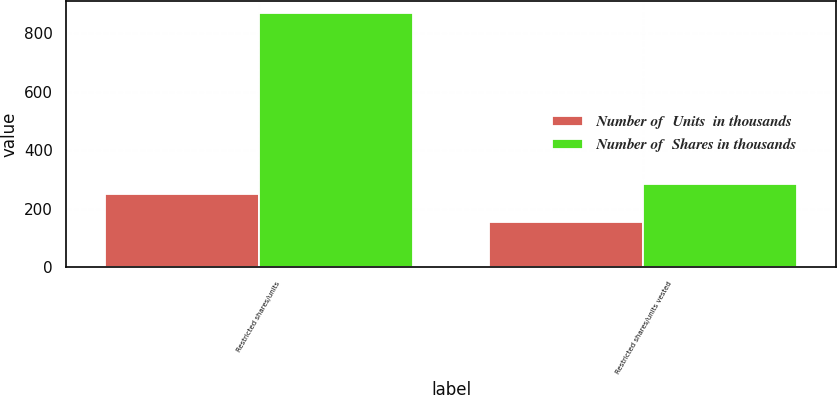Convert chart to OTSL. <chart><loc_0><loc_0><loc_500><loc_500><stacked_bar_chart><ecel><fcel>Restricted shares/units<fcel>Restricted shares/units vested<nl><fcel>Number of  Units  in thousands<fcel>250<fcel>156<nl><fcel>Number of  Shares in thousands<fcel>867<fcel>283<nl></chart> 